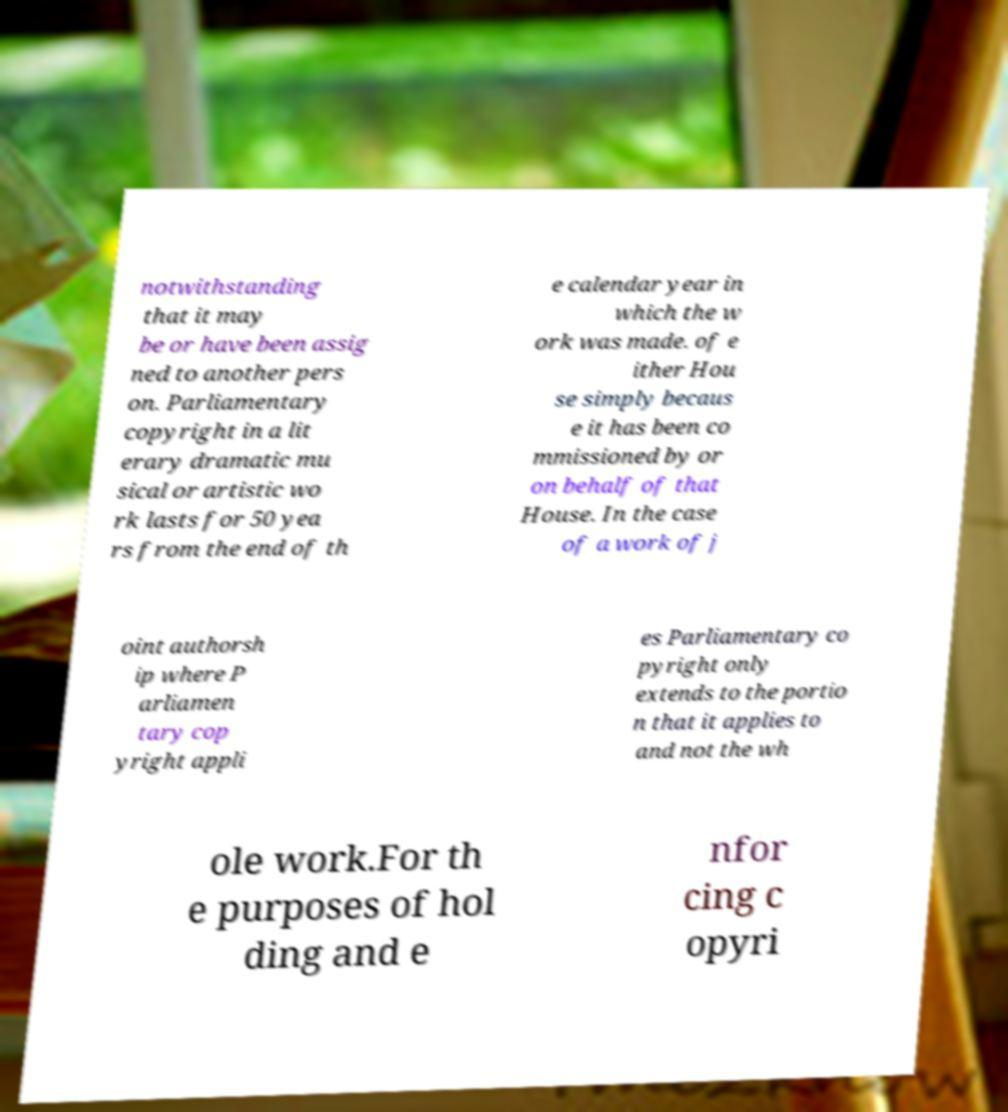Please read and relay the text visible in this image. What does it say? notwithstanding that it may be or have been assig ned to another pers on. Parliamentary copyright in a lit erary dramatic mu sical or artistic wo rk lasts for 50 yea rs from the end of th e calendar year in which the w ork was made. of e ither Hou se simply becaus e it has been co mmissioned by or on behalf of that House. In the case of a work of j oint authorsh ip where P arliamen tary cop yright appli es Parliamentary co pyright only extends to the portio n that it applies to and not the wh ole work.For th e purposes of hol ding and e nfor cing c opyri 